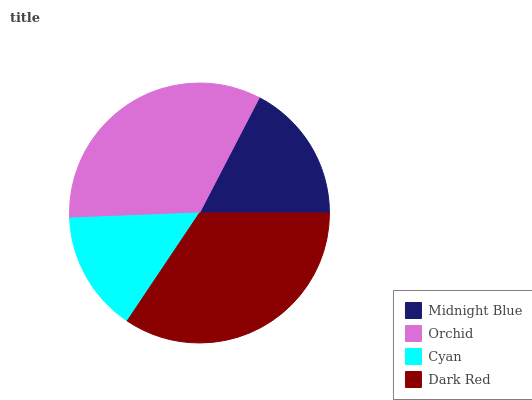Is Cyan the minimum?
Answer yes or no. Yes. Is Dark Red the maximum?
Answer yes or no. Yes. Is Orchid the minimum?
Answer yes or no. No. Is Orchid the maximum?
Answer yes or no. No. Is Orchid greater than Midnight Blue?
Answer yes or no. Yes. Is Midnight Blue less than Orchid?
Answer yes or no. Yes. Is Midnight Blue greater than Orchid?
Answer yes or no. No. Is Orchid less than Midnight Blue?
Answer yes or no. No. Is Orchid the high median?
Answer yes or no. Yes. Is Midnight Blue the low median?
Answer yes or no. Yes. Is Cyan the high median?
Answer yes or no. No. Is Dark Red the low median?
Answer yes or no. No. 